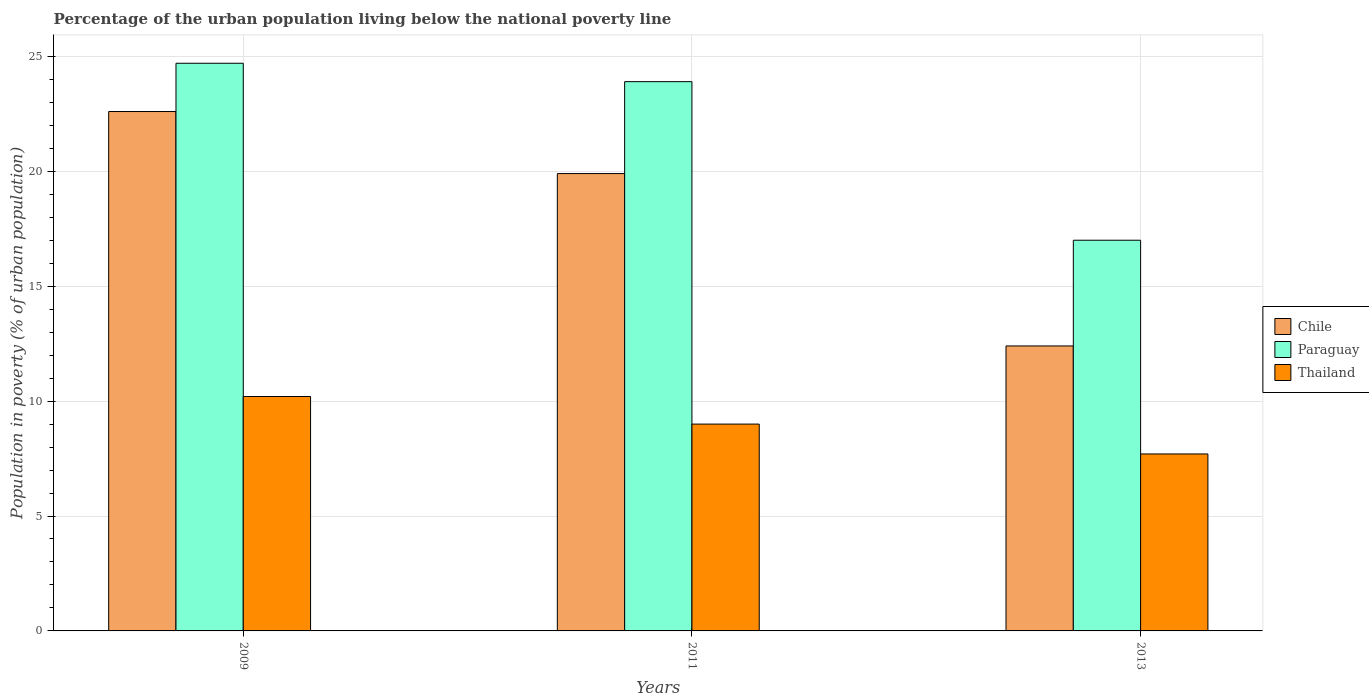How many groups of bars are there?
Offer a terse response. 3. Are the number of bars per tick equal to the number of legend labels?
Offer a terse response. Yes. Are the number of bars on each tick of the X-axis equal?
Your answer should be very brief. Yes. How many bars are there on the 1st tick from the left?
Provide a succinct answer. 3. How many bars are there on the 2nd tick from the right?
Your answer should be compact. 3. What is the label of the 3rd group of bars from the left?
Provide a succinct answer. 2013. In how many cases, is the number of bars for a given year not equal to the number of legend labels?
Your response must be concise. 0. Across all years, what is the maximum percentage of the urban population living below the national poverty line in Chile?
Ensure brevity in your answer.  22.6. In which year was the percentage of the urban population living below the national poverty line in Chile maximum?
Provide a short and direct response. 2009. In which year was the percentage of the urban population living below the national poverty line in Thailand minimum?
Your answer should be compact. 2013. What is the total percentage of the urban population living below the national poverty line in Paraguay in the graph?
Offer a very short reply. 65.6. What is the difference between the percentage of the urban population living below the national poverty line in Paraguay in 2009 and that in 2011?
Your answer should be very brief. 0.8. What is the difference between the percentage of the urban population living below the national poverty line in Thailand in 2011 and the percentage of the urban population living below the national poverty line in Paraguay in 2009?
Provide a short and direct response. -15.7. In the year 2011, what is the difference between the percentage of the urban population living below the national poverty line in Paraguay and percentage of the urban population living below the national poverty line in Thailand?
Provide a short and direct response. 14.9. In how many years, is the percentage of the urban population living below the national poverty line in Thailand greater than 2 %?
Provide a short and direct response. 3. What is the ratio of the percentage of the urban population living below the national poverty line in Thailand in 2011 to that in 2013?
Your response must be concise. 1.17. What is the difference between the highest and the second highest percentage of the urban population living below the national poverty line in Paraguay?
Your response must be concise. 0.8. What is the difference between the highest and the lowest percentage of the urban population living below the national poverty line in Chile?
Offer a very short reply. 10.2. Is the sum of the percentage of the urban population living below the national poverty line in Chile in 2011 and 2013 greater than the maximum percentage of the urban population living below the national poverty line in Paraguay across all years?
Your answer should be very brief. Yes. What does the 3rd bar from the left in 2011 represents?
Offer a terse response. Thailand. What does the 2nd bar from the right in 2011 represents?
Make the answer very short. Paraguay. Are all the bars in the graph horizontal?
Your answer should be very brief. No. How many years are there in the graph?
Keep it short and to the point. 3. What is the difference between two consecutive major ticks on the Y-axis?
Provide a short and direct response. 5. Does the graph contain any zero values?
Ensure brevity in your answer.  No. Does the graph contain grids?
Make the answer very short. Yes. How many legend labels are there?
Provide a succinct answer. 3. What is the title of the graph?
Provide a succinct answer. Percentage of the urban population living below the national poverty line. What is the label or title of the Y-axis?
Your answer should be very brief. Population in poverty (% of urban population). What is the Population in poverty (% of urban population) of Chile in 2009?
Provide a short and direct response. 22.6. What is the Population in poverty (% of urban population) in Paraguay in 2009?
Your answer should be very brief. 24.7. What is the Population in poverty (% of urban population) of Thailand in 2009?
Your answer should be very brief. 10.2. What is the Population in poverty (% of urban population) in Paraguay in 2011?
Keep it short and to the point. 23.9. What is the Population in poverty (% of urban population) of Thailand in 2011?
Provide a succinct answer. 9. What is the Population in poverty (% of urban population) of Paraguay in 2013?
Ensure brevity in your answer.  17. Across all years, what is the maximum Population in poverty (% of urban population) of Chile?
Keep it short and to the point. 22.6. Across all years, what is the maximum Population in poverty (% of urban population) in Paraguay?
Offer a terse response. 24.7. Across all years, what is the minimum Population in poverty (% of urban population) of Chile?
Your answer should be compact. 12.4. Across all years, what is the minimum Population in poverty (% of urban population) of Paraguay?
Give a very brief answer. 17. Across all years, what is the minimum Population in poverty (% of urban population) of Thailand?
Your response must be concise. 7.7. What is the total Population in poverty (% of urban population) of Chile in the graph?
Ensure brevity in your answer.  54.9. What is the total Population in poverty (% of urban population) of Paraguay in the graph?
Make the answer very short. 65.6. What is the total Population in poverty (% of urban population) in Thailand in the graph?
Offer a terse response. 26.9. What is the difference between the Population in poverty (% of urban population) in Paraguay in 2009 and that in 2013?
Your response must be concise. 7.7. What is the difference between the Population in poverty (% of urban population) of Paraguay in 2011 and that in 2013?
Your answer should be compact. 6.9. What is the difference between the Population in poverty (% of urban population) of Thailand in 2011 and that in 2013?
Your response must be concise. 1.3. What is the difference between the Population in poverty (% of urban population) of Chile in 2009 and the Population in poverty (% of urban population) of Paraguay in 2011?
Make the answer very short. -1.3. What is the difference between the Population in poverty (% of urban population) of Chile in 2009 and the Population in poverty (% of urban population) of Thailand in 2011?
Your answer should be compact. 13.6. What is the difference between the Population in poverty (% of urban population) in Chile in 2009 and the Population in poverty (% of urban population) in Paraguay in 2013?
Your answer should be very brief. 5.6. What is the difference between the Population in poverty (% of urban population) in Chile in 2009 and the Population in poverty (% of urban population) in Thailand in 2013?
Give a very brief answer. 14.9. What is the difference between the Population in poverty (% of urban population) in Chile in 2011 and the Population in poverty (% of urban population) in Paraguay in 2013?
Keep it short and to the point. 2.9. What is the difference between the Population in poverty (% of urban population) in Paraguay in 2011 and the Population in poverty (% of urban population) in Thailand in 2013?
Ensure brevity in your answer.  16.2. What is the average Population in poverty (% of urban population) in Chile per year?
Ensure brevity in your answer.  18.3. What is the average Population in poverty (% of urban population) of Paraguay per year?
Ensure brevity in your answer.  21.87. What is the average Population in poverty (% of urban population) of Thailand per year?
Provide a succinct answer. 8.97. In the year 2009, what is the difference between the Population in poverty (% of urban population) in Chile and Population in poverty (% of urban population) in Paraguay?
Give a very brief answer. -2.1. In the year 2009, what is the difference between the Population in poverty (% of urban population) of Chile and Population in poverty (% of urban population) of Thailand?
Make the answer very short. 12.4. In the year 2011, what is the difference between the Population in poverty (% of urban population) of Chile and Population in poverty (% of urban population) of Paraguay?
Offer a very short reply. -4. In the year 2011, what is the difference between the Population in poverty (% of urban population) of Chile and Population in poverty (% of urban population) of Thailand?
Your answer should be compact. 10.9. In the year 2011, what is the difference between the Population in poverty (% of urban population) of Paraguay and Population in poverty (% of urban population) of Thailand?
Ensure brevity in your answer.  14.9. In the year 2013, what is the difference between the Population in poverty (% of urban population) in Chile and Population in poverty (% of urban population) in Paraguay?
Your response must be concise. -4.6. In the year 2013, what is the difference between the Population in poverty (% of urban population) of Chile and Population in poverty (% of urban population) of Thailand?
Provide a short and direct response. 4.7. What is the ratio of the Population in poverty (% of urban population) of Chile in 2009 to that in 2011?
Keep it short and to the point. 1.14. What is the ratio of the Population in poverty (% of urban population) in Paraguay in 2009 to that in 2011?
Offer a terse response. 1.03. What is the ratio of the Population in poverty (% of urban population) of Thailand in 2009 to that in 2011?
Offer a terse response. 1.13. What is the ratio of the Population in poverty (% of urban population) of Chile in 2009 to that in 2013?
Your answer should be compact. 1.82. What is the ratio of the Population in poverty (% of urban population) of Paraguay in 2009 to that in 2013?
Ensure brevity in your answer.  1.45. What is the ratio of the Population in poverty (% of urban population) in Thailand in 2009 to that in 2013?
Provide a short and direct response. 1.32. What is the ratio of the Population in poverty (% of urban population) in Chile in 2011 to that in 2013?
Your response must be concise. 1.6. What is the ratio of the Population in poverty (% of urban population) in Paraguay in 2011 to that in 2013?
Make the answer very short. 1.41. What is the ratio of the Population in poverty (% of urban population) in Thailand in 2011 to that in 2013?
Your response must be concise. 1.17. What is the difference between the highest and the second highest Population in poverty (% of urban population) of Chile?
Offer a very short reply. 2.7. What is the difference between the highest and the second highest Population in poverty (% of urban population) in Thailand?
Your answer should be compact. 1.2. What is the difference between the highest and the lowest Population in poverty (% of urban population) in Thailand?
Ensure brevity in your answer.  2.5. 